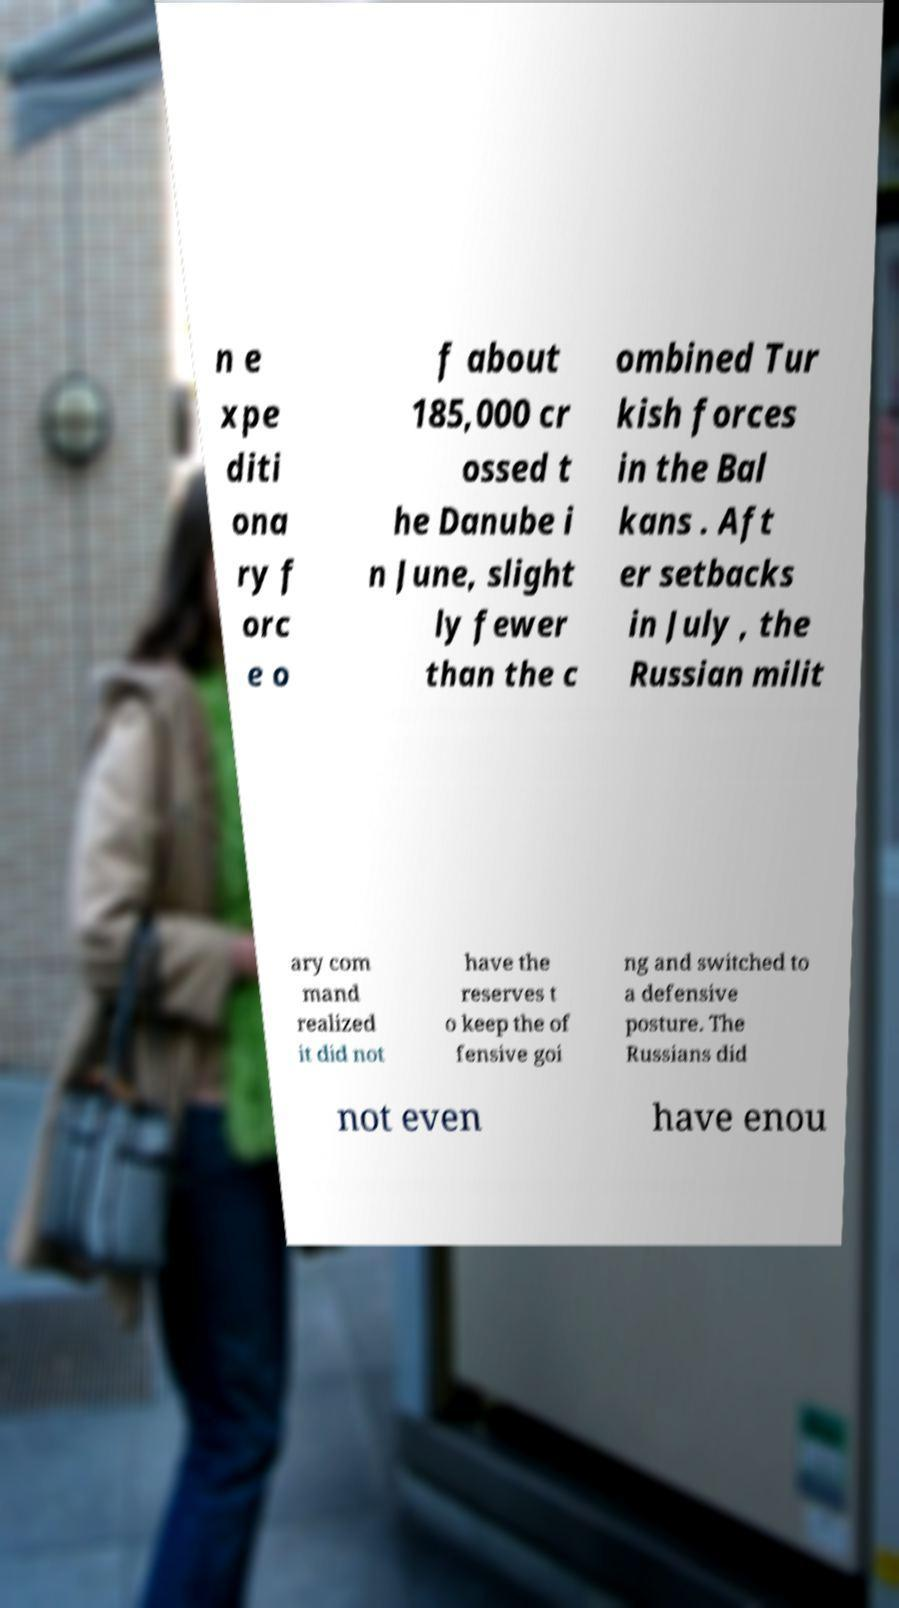For documentation purposes, I need the text within this image transcribed. Could you provide that? n e xpe diti ona ry f orc e o f about 185,000 cr ossed t he Danube i n June, slight ly fewer than the c ombined Tur kish forces in the Bal kans . Aft er setbacks in July , the Russian milit ary com mand realized it did not have the reserves t o keep the of fensive goi ng and switched to a defensive posture. The Russians did not even have enou 